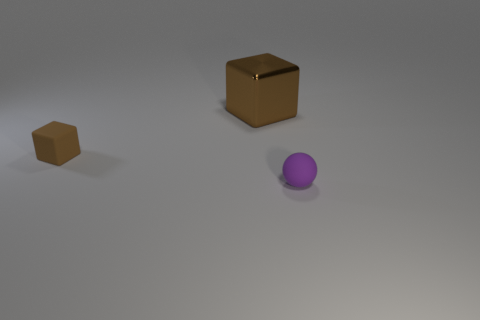Add 3 small brown things. How many objects exist? 6 Subtract all spheres. How many objects are left? 2 Add 1 big objects. How many big objects are left? 2 Add 2 big green balls. How many big green balls exist? 2 Subtract 0 brown cylinders. How many objects are left? 3 Subtract all green shiny objects. Subtract all brown cubes. How many objects are left? 1 